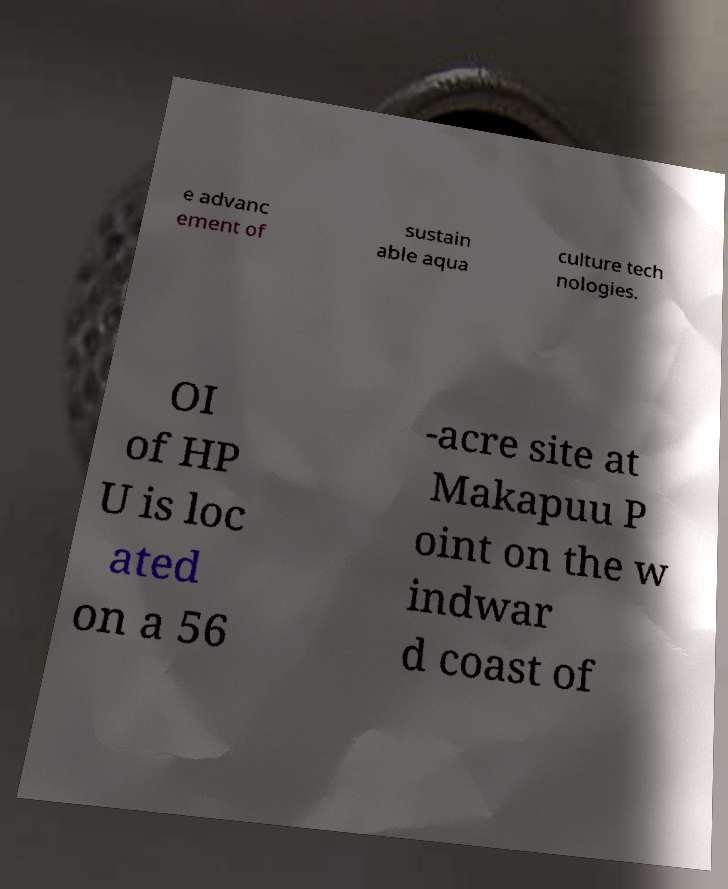Can you read and provide the text displayed in the image?This photo seems to have some interesting text. Can you extract and type it out for me? e advanc ement of sustain able aqua culture tech nologies. OI of HP U is loc ated on a 56 -acre site at Makapuu P oint on the w indwar d coast of 